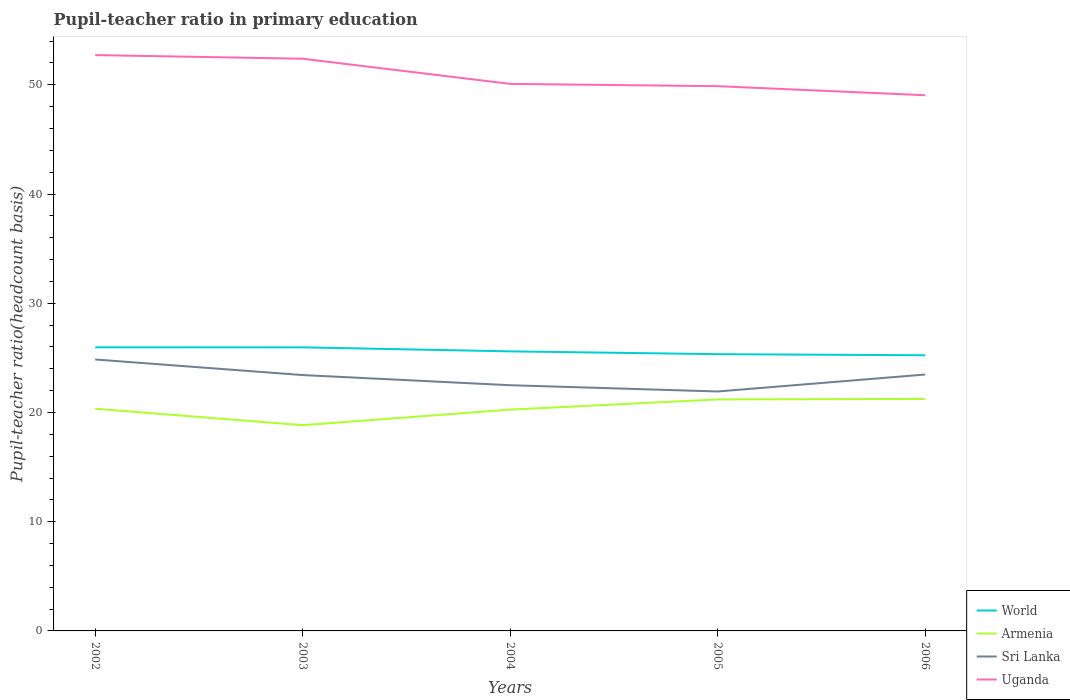How many different coloured lines are there?
Your answer should be very brief. 4. Does the line corresponding to World intersect with the line corresponding to Sri Lanka?
Provide a short and direct response. No. Is the number of lines equal to the number of legend labels?
Provide a succinct answer. Yes. Across all years, what is the maximum pupil-teacher ratio in primary education in Sri Lanka?
Offer a very short reply. 21.92. In which year was the pupil-teacher ratio in primary education in Armenia maximum?
Your response must be concise. 2003. What is the total pupil-teacher ratio in primary education in World in the graph?
Keep it short and to the point. 0.26. What is the difference between the highest and the second highest pupil-teacher ratio in primary education in Uganda?
Keep it short and to the point. 3.68. How many lines are there?
Your response must be concise. 4. Are the values on the major ticks of Y-axis written in scientific E-notation?
Your response must be concise. No. Does the graph contain grids?
Ensure brevity in your answer.  No. How are the legend labels stacked?
Offer a very short reply. Vertical. What is the title of the graph?
Provide a succinct answer. Pupil-teacher ratio in primary education. Does "Eritrea" appear as one of the legend labels in the graph?
Ensure brevity in your answer.  No. What is the label or title of the X-axis?
Offer a terse response. Years. What is the label or title of the Y-axis?
Your response must be concise. Pupil-teacher ratio(headcount basis). What is the Pupil-teacher ratio(headcount basis) in World in 2002?
Provide a succinct answer. 25.97. What is the Pupil-teacher ratio(headcount basis) of Armenia in 2002?
Offer a very short reply. 20.34. What is the Pupil-teacher ratio(headcount basis) of Sri Lanka in 2002?
Offer a terse response. 24.85. What is the Pupil-teacher ratio(headcount basis) of Uganda in 2002?
Keep it short and to the point. 52.72. What is the Pupil-teacher ratio(headcount basis) of World in 2003?
Your answer should be compact. 25.97. What is the Pupil-teacher ratio(headcount basis) in Armenia in 2003?
Offer a very short reply. 18.84. What is the Pupil-teacher ratio(headcount basis) of Sri Lanka in 2003?
Your answer should be very brief. 23.43. What is the Pupil-teacher ratio(headcount basis) of Uganda in 2003?
Your answer should be very brief. 52.39. What is the Pupil-teacher ratio(headcount basis) of World in 2004?
Your answer should be very brief. 25.6. What is the Pupil-teacher ratio(headcount basis) of Armenia in 2004?
Your answer should be compact. 20.26. What is the Pupil-teacher ratio(headcount basis) of Sri Lanka in 2004?
Provide a succinct answer. 22.5. What is the Pupil-teacher ratio(headcount basis) of Uganda in 2004?
Keep it short and to the point. 50.09. What is the Pupil-teacher ratio(headcount basis) of World in 2005?
Ensure brevity in your answer.  25.34. What is the Pupil-teacher ratio(headcount basis) in Armenia in 2005?
Give a very brief answer. 21.2. What is the Pupil-teacher ratio(headcount basis) of Sri Lanka in 2005?
Give a very brief answer. 21.92. What is the Pupil-teacher ratio(headcount basis) in Uganda in 2005?
Your answer should be compact. 49.88. What is the Pupil-teacher ratio(headcount basis) in World in 2006?
Keep it short and to the point. 25.24. What is the Pupil-teacher ratio(headcount basis) of Armenia in 2006?
Make the answer very short. 21.24. What is the Pupil-teacher ratio(headcount basis) of Sri Lanka in 2006?
Offer a very short reply. 23.48. What is the Pupil-teacher ratio(headcount basis) in Uganda in 2006?
Your response must be concise. 49.05. Across all years, what is the maximum Pupil-teacher ratio(headcount basis) in World?
Your answer should be compact. 25.97. Across all years, what is the maximum Pupil-teacher ratio(headcount basis) in Armenia?
Offer a terse response. 21.24. Across all years, what is the maximum Pupil-teacher ratio(headcount basis) in Sri Lanka?
Offer a very short reply. 24.85. Across all years, what is the maximum Pupil-teacher ratio(headcount basis) of Uganda?
Keep it short and to the point. 52.72. Across all years, what is the minimum Pupil-teacher ratio(headcount basis) in World?
Make the answer very short. 25.24. Across all years, what is the minimum Pupil-teacher ratio(headcount basis) of Armenia?
Offer a very short reply. 18.84. Across all years, what is the minimum Pupil-teacher ratio(headcount basis) in Sri Lanka?
Your answer should be very brief. 21.92. Across all years, what is the minimum Pupil-teacher ratio(headcount basis) of Uganda?
Give a very brief answer. 49.05. What is the total Pupil-teacher ratio(headcount basis) of World in the graph?
Give a very brief answer. 128.11. What is the total Pupil-teacher ratio(headcount basis) of Armenia in the graph?
Your answer should be compact. 101.88. What is the total Pupil-teacher ratio(headcount basis) of Sri Lanka in the graph?
Give a very brief answer. 116.18. What is the total Pupil-teacher ratio(headcount basis) of Uganda in the graph?
Your answer should be very brief. 254.12. What is the difference between the Pupil-teacher ratio(headcount basis) in World in 2002 and that in 2003?
Provide a short and direct response. 0. What is the difference between the Pupil-teacher ratio(headcount basis) in Armenia in 2002 and that in 2003?
Provide a short and direct response. 1.51. What is the difference between the Pupil-teacher ratio(headcount basis) in Sri Lanka in 2002 and that in 2003?
Provide a succinct answer. 1.43. What is the difference between the Pupil-teacher ratio(headcount basis) in Uganda in 2002 and that in 2003?
Offer a very short reply. 0.33. What is the difference between the Pupil-teacher ratio(headcount basis) of World in 2002 and that in 2004?
Provide a succinct answer. 0.37. What is the difference between the Pupil-teacher ratio(headcount basis) of Armenia in 2002 and that in 2004?
Your answer should be compact. 0.08. What is the difference between the Pupil-teacher ratio(headcount basis) in Sri Lanka in 2002 and that in 2004?
Provide a succinct answer. 2.36. What is the difference between the Pupil-teacher ratio(headcount basis) in Uganda in 2002 and that in 2004?
Keep it short and to the point. 2.64. What is the difference between the Pupil-teacher ratio(headcount basis) in World in 2002 and that in 2005?
Give a very brief answer. 0.63. What is the difference between the Pupil-teacher ratio(headcount basis) in Armenia in 2002 and that in 2005?
Offer a very short reply. -0.85. What is the difference between the Pupil-teacher ratio(headcount basis) in Sri Lanka in 2002 and that in 2005?
Make the answer very short. 2.93. What is the difference between the Pupil-teacher ratio(headcount basis) in Uganda in 2002 and that in 2005?
Keep it short and to the point. 2.85. What is the difference between the Pupil-teacher ratio(headcount basis) in World in 2002 and that in 2006?
Make the answer very short. 0.73. What is the difference between the Pupil-teacher ratio(headcount basis) in Armenia in 2002 and that in 2006?
Keep it short and to the point. -0.9. What is the difference between the Pupil-teacher ratio(headcount basis) of Sri Lanka in 2002 and that in 2006?
Make the answer very short. 1.38. What is the difference between the Pupil-teacher ratio(headcount basis) of Uganda in 2002 and that in 2006?
Offer a terse response. 3.68. What is the difference between the Pupil-teacher ratio(headcount basis) of World in 2003 and that in 2004?
Make the answer very short. 0.37. What is the difference between the Pupil-teacher ratio(headcount basis) of Armenia in 2003 and that in 2004?
Your response must be concise. -1.43. What is the difference between the Pupil-teacher ratio(headcount basis) in Sri Lanka in 2003 and that in 2004?
Offer a very short reply. 0.93. What is the difference between the Pupil-teacher ratio(headcount basis) of Uganda in 2003 and that in 2004?
Provide a short and direct response. 2.3. What is the difference between the Pupil-teacher ratio(headcount basis) in World in 2003 and that in 2005?
Your answer should be very brief. 0.63. What is the difference between the Pupil-teacher ratio(headcount basis) in Armenia in 2003 and that in 2005?
Keep it short and to the point. -2.36. What is the difference between the Pupil-teacher ratio(headcount basis) in Sri Lanka in 2003 and that in 2005?
Your answer should be very brief. 1.5. What is the difference between the Pupil-teacher ratio(headcount basis) of Uganda in 2003 and that in 2005?
Keep it short and to the point. 2.51. What is the difference between the Pupil-teacher ratio(headcount basis) of World in 2003 and that in 2006?
Ensure brevity in your answer.  0.73. What is the difference between the Pupil-teacher ratio(headcount basis) in Armenia in 2003 and that in 2006?
Offer a terse response. -2.4. What is the difference between the Pupil-teacher ratio(headcount basis) of Sri Lanka in 2003 and that in 2006?
Give a very brief answer. -0.05. What is the difference between the Pupil-teacher ratio(headcount basis) in Uganda in 2003 and that in 2006?
Your answer should be very brief. 3.34. What is the difference between the Pupil-teacher ratio(headcount basis) of World in 2004 and that in 2005?
Make the answer very short. 0.26. What is the difference between the Pupil-teacher ratio(headcount basis) of Armenia in 2004 and that in 2005?
Your answer should be compact. -0.93. What is the difference between the Pupil-teacher ratio(headcount basis) of Sri Lanka in 2004 and that in 2005?
Offer a very short reply. 0.57. What is the difference between the Pupil-teacher ratio(headcount basis) of Uganda in 2004 and that in 2005?
Provide a short and direct response. 0.21. What is the difference between the Pupil-teacher ratio(headcount basis) of World in 2004 and that in 2006?
Make the answer very short. 0.36. What is the difference between the Pupil-teacher ratio(headcount basis) in Armenia in 2004 and that in 2006?
Offer a very short reply. -0.98. What is the difference between the Pupil-teacher ratio(headcount basis) of Sri Lanka in 2004 and that in 2006?
Provide a succinct answer. -0.98. What is the difference between the Pupil-teacher ratio(headcount basis) in Uganda in 2004 and that in 2006?
Your answer should be very brief. 1.04. What is the difference between the Pupil-teacher ratio(headcount basis) in World in 2005 and that in 2006?
Your response must be concise. 0.1. What is the difference between the Pupil-teacher ratio(headcount basis) of Armenia in 2005 and that in 2006?
Give a very brief answer. -0.04. What is the difference between the Pupil-teacher ratio(headcount basis) of Sri Lanka in 2005 and that in 2006?
Give a very brief answer. -1.55. What is the difference between the Pupil-teacher ratio(headcount basis) in Uganda in 2005 and that in 2006?
Provide a short and direct response. 0.83. What is the difference between the Pupil-teacher ratio(headcount basis) of World in 2002 and the Pupil-teacher ratio(headcount basis) of Armenia in 2003?
Give a very brief answer. 7.13. What is the difference between the Pupil-teacher ratio(headcount basis) of World in 2002 and the Pupil-teacher ratio(headcount basis) of Sri Lanka in 2003?
Provide a short and direct response. 2.54. What is the difference between the Pupil-teacher ratio(headcount basis) of World in 2002 and the Pupil-teacher ratio(headcount basis) of Uganda in 2003?
Give a very brief answer. -26.42. What is the difference between the Pupil-teacher ratio(headcount basis) of Armenia in 2002 and the Pupil-teacher ratio(headcount basis) of Sri Lanka in 2003?
Offer a very short reply. -3.08. What is the difference between the Pupil-teacher ratio(headcount basis) of Armenia in 2002 and the Pupil-teacher ratio(headcount basis) of Uganda in 2003?
Give a very brief answer. -32.05. What is the difference between the Pupil-teacher ratio(headcount basis) in Sri Lanka in 2002 and the Pupil-teacher ratio(headcount basis) in Uganda in 2003?
Your answer should be compact. -27.54. What is the difference between the Pupil-teacher ratio(headcount basis) of World in 2002 and the Pupil-teacher ratio(headcount basis) of Armenia in 2004?
Offer a terse response. 5.71. What is the difference between the Pupil-teacher ratio(headcount basis) in World in 2002 and the Pupil-teacher ratio(headcount basis) in Sri Lanka in 2004?
Your response must be concise. 3.47. What is the difference between the Pupil-teacher ratio(headcount basis) in World in 2002 and the Pupil-teacher ratio(headcount basis) in Uganda in 2004?
Offer a terse response. -24.12. What is the difference between the Pupil-teacher ratio(headcount basis) of Armenia in 2002 and the Pupil-teacher ratio(headcount basis) of Sri Lanka in 2004?
Your answer should be compact. -2.15. What is the difference between the Pupil-teacher ratio(headcount basis) of Armenia in 2002 and the Pupil-teacher ratio(headcount basis) of Uganda in 2004?
Your answer should be compact. -29.74. What is the difference between the Pupil-teacher ratio(headcount basis) in Sri Lanka in 2002 and the Pupil-teacher ratio(headcount basis) in Uganda in 2004?
Offer a very short reply. -25.23. What is the difference between the Pupil-teacher ratio(headcount basis) in World in 2002 and the Pupil-teacher ratio(headcount basis) in Armenia in 2005?
Your answer should be compact. 4.77. What is the difference between the Pupil-teacher ratio(headcount basis) of World in 2002 and the Pupil-teacher ratio(headcount basis) of Sri Lanka in 2005?
Your answer should be very brief. 4.04. What is the difference between the Pupil-teacher ratio(headcount basis) in World in 2002 and the Pupil-teacher ratio(headcount basis) in Uganda in 2005?
Your answer should be compact. -23.91. What is the difference between the Pupil-teacher ratio(headcount basis) of Armenia in 2002 and the Pupil-teacher ratio(headcount basis) of Sri Lanka in 2005?
Offer a terse response. -1.58. What is the difference between the Pupil-teacher ratio(headcount basis) of Armenia in 2002 and the Pupil-teacher ratio(headcount basis) of Uganda in 2005?
Provide a succinct answer. -29.53. What is the difference between the Pupil-teacher ratio(headcount basis) of Sri Lanka in 2002 and the Pupil-teacher ratio(headcount basis) of Uganda in 2005?
Give a very brief answer. -25.02. What is the difference between the Pupil-teacher ratio(headcount basis) in World in 2002 and the Pupil-teacher ratio(headcount basis) in Armenia in 2006?
Provide a succinct answer. 4.73. What is the difference between the Pupil-teacher ratio(headcount basis) in World in 2002 and the Pupil-teacher ratio(headcount basis) in Sri Lanka in 2006?
Your answer should be very brief. 2.49. What is the difference between the Pupil-teacher ratio(headcount basis) of World in 2002 and the Pupil-teacher ratio(headcount basis) of Uganda in 2006?
Provide a short and direct response. -23.08. What is the difference between the Pupil-teacher ratio(headcount basis) in Armenia in 2002 and the Pupil-teacher ratio(headcount basis) in Sri Lanka in 2006?
Your response must be concise. -3.13. What is the difference between the Pupil-teacher ratio(headcount basis) of Armenia in 2002 and the Pupil-teacher ratio(headcount basis) of Uganda in 2006?
Give a very brief answer. -28.7. What is the difference between the Pupil-teacher ratio(headcount basis) of Sri Lanka in 2002 and the Pupil-teacher ratio(headcount basis) of Uganda in 2006?
Ensure brevity in your answer.  -24.19. What is the difference between the Pupil-teacher ratio(headcount basis) in World in 2003 and the Pupil-teacher ratio(headcount basis) in Armenia in 2004?
Offer a terse response. 5.7. What is the difference between the Pupil-teacher ratio(headcount basis) in World in 2003 and the Pupil-teacher ratio(headcount basis) in Sri Lanka in 2004?
Provide a short and direct response. 3.47. What is the difference between the Pupil-teacher ratio(headcount basis) of World in 2003 and the Pupil-teacher ratio(headcount basis) of Uganda in 2004?
Ensure brevity in your answer.  -24.12. What is the difference between the Pupil-teacher ratio(headcount basis) of Armenia in 2003 and the Pupil-teacher ratio(headcount basis) of Sri Lanka in 2004?
Provide a short and direct response. -3.66. What is the difference between the Pupil-teacher ratio(headcount basis) in Armenia in 2003 and the Pupil-teacher ratio(headcount basis) in Uganda in 2004?
Keep it short and to the point. -31.25. What is the difference between the Pupil-teacher ratio(headcount basis) in Sri Lanka in 2003 and the Pupil-teacher ratio(headcount basis) in Uganda in 2004?
Your answer should be compact. -26.66. What is the difference between the Pupil-teacher ratio(headcount basis) in World in 2003 and the Pupil-teacher ratio(headcount basis) in Armenia in 2005?
Your answer should be compact. 4.77. What is the difference between the Pupil-teacher ratio(headcount basis) in World in 2003 and the Pupil-teacher ratio(headcount basis) in Sri Lanka in 2005?
Offer a terse response. 4.04. What is the difference between the Pupil-teacher ratio(headcount basis) in World in 2003 and the Pupil-teacher ratio(headcount basis) in Uganda in 2005?
Your answer should be very brief. -23.91. What is the difference between the Pupil-teacher ratio(headcount basis) in Armenia in 2003 and the Pupil-teacher ratio(headcount basis) in Sri Lanka in 2005?
Offer a very short reply. -3.09. What is the difference between the Pupil-teacher ratio(headcount basis) in Armenia in 2003 and the Pupil-teacher ratio(headcount basis) in Uganda in 2005?
Your response must be concise. -31.04. What is the difference between the Pupil-teacher ratio(headcount basis) of Sri Lanka in 2003 and the Pupil-teacher ratio(headcount basis) of Uganda in 2005?
Your answer should be compact. -26.45. What is the difference between the Pupil-teacher ratio(headcount basis) of World in 2003 and the Pupil-teacher ratio(headcount basis) of Armenia in 2006?
Keep it short and to the point. 4.72. What is the difference between the Pupil-teacher ratio(headcount basis) in World in 2003 and the Pupil-teacher ratio(headcount basis) in Sri Lanka in 2006?
Offer a very short reply. 2.49. What is the difference between the Pupil-teacher ratio(headcount basis) in World in 2003 and the Pupil-teacher ratio(headcount basis) in Uganda in 2006?
Your answer should be compact. -23.08. What is the difference between the Pupil-teacher ratio(headcount basis) in Armenia in 2003 and the Pupil-teacher ratio(headcount basis) in Sri Lanka in 2006?
Offer a terse response. -4.64. What is the difference between the Pupil-teacher ratio(headcount basis) in Armenia in 2003 and the Pupil-teacher ratio(headcount basis) in Uganda in 2006?
Your response must be concise. -30.21. What is the difference between the Pupil-teacher ratio(headcount basis) of Sri Lanka in 2003 and the Pupil-teacher ratio(headcount basis) of Uganda in 2006?
Your response must be concise. -25.62. What is the difference between the Pupil-teacher ratio(headcount basis) of World in 2004 and the Pupil-teacher ratio(headcount basis) of Armenia in 2005?
Provide a short and direct response. 4.4. What is the difference between the Pupil-teacher ratio(headcount basis) in World in 2004 and the Pupil-teacher ratio(headcount basis) in Sri Lanka in 2005?
Give a very brief answer. 3.67. What is the difference between the Pupil-teacher ratio(headcount basis) of World in 2004 and the Pupil-teacher ratio(headcount basis) of Uganda in 2005?
Offer a very short reply. -24.28. What is the difference between the Pupil-teacher ratio(headcount basis) of Armenia in 2004 and the Pupil-teacher ratio(headcount basis) of Sri Lanka in 2005?
Provide a short and direct response. -1.66. What is the difference between the Pupil-teacher ratio(headcount basis) of Armenia in 2004 and the Pupil-teacher ratio(headcount basis) of Uganda in 2005?
Keep it short and to the point. -29.62. What is the difference between the Pupil-teacher ratio(headcount basis) of Sri Lanka in 2004 and the Pupil-teacher ratio(headcount basis) of Uganda in 2005?
Provide a short and direct response. -27.38. What is the difference between the Pupil-teacher ratio(headcount basis) of World in 2004 and the Pupil-teacher ratio(headcount basis) of Armenia in 2006?
Give a very brief answer. 4.35. What is the difference between the Pupil-teacher ratio(headcount basis) in World in 2004 and the Pupil-teacher ratio(headcount basis) in Sri Lanka in 2006?
Keep it short and to the point. 2.12. What is the difference between the Pupil-teacher ratio(headcount basis) of World in 2004 and the Pupil-teacher ratio(headcount basis) of Uganda in 2006?
Provide a short and direct response. -23.45. What is the difference between the Pupil-teacher ratio(headcount basis) in Armenia in 2004 and the Pupil-teacher ratio(headcount basis) in Sri Lanka in 2006?
Keep it short and to the point. -3.21. What is the difference between the Pupil-teacher ratio(headcount basis) in Armenia in 2004 and the Pupil-teacher ratio(headcount basis) in Uganda in 2006?
Your answer should be compact. -28.78. What is the difference between the Pupil-teacher ratio(headcount basis) of Sri Lanka in 2004 and the Pupil-teacher ratio(headcount basis) of Uganda in 2006?
Keep it short and to the point. -26.55. What is the difference between the Pupil-teacher ratio(headcount basis) of World in 2005 and the Pupil-teacher ratio(headcount basis) of Armenia in 2006?
Ensure brevity in your answer.  4.1. What is the difference between the Pupil-teacher ratio(headcount basis) of World in 2005 and the Pupil-teacher ratio(headcount basis) of Sri Lanka in 2006?
Keep it short and to the point. 1.86. What is the difference between the Pupil-teacher ratio(headcount basis) in World in 2005 and the Pupil-teacher ratio(headcount basis) in Uganda in 2006?
Keep it short and to the point. -23.71. What is the difference between the Pupil-teacher ratio(headcount basis) in Armenia in 2005 and the Pupil-teacher ratio(headcount basis) in Sri Lanka in 2006?
Your answer should be compact. -2.28. What is the difference between the Pupil-teacher ratio(headcount basis) in Armenia in 2005 and the Pupil-teacher ratio(headcount basis) in Uganda in 2006?
Your response must be concise. -27.85. What is the difference between the Pupil-teacher ratio(headcount basis) in Sri Lanka in 2005 and the Pupil-teacher ratio(headcount basis) in Uganda in 2006?
Provide a short and direct response. -27.12. What is the average Pupil-teacher ratio(headcount basis) in World per year?
Your answer should be very brief. 25.62. What is the average Pupil-teacher ratio(headcount basis) in Armenia per year?
Provide a succinct answer. 20.38. What is the average Pupil-teacher ratio(headcount basis) of Sri Lanka per year?
Your response must be concise. 23.24. What is the average Pupil-teacher ratio(headcount basis) of Uganda per year?
Keep it short and to the point. 50.83. In the year 2002, what is the difference between the Pupil-teacher ratio(headcount basis) in World and Pupil-teacher ratio(headcount basis) in Armenia?
Offer a terse response. 5.62. In the year 2002, what is the difference between the Pupil-teacher ratio(headcount basis) of World and Pupil-teacher ratio(headcount basis) of Sri Lanka?
Your response must be concise. 1.12. In the year 2002, what is the difference between the Pupil-teacher ratio(headcount basis) of World and Pupil-teacher ratio(headcount basis) of Uganda?
Offer a terse response. -26.76. In the year 2002, what is the difference between the Pupil-teacher ratio(headcount basis) in Armenia and Pupil-teacher ratio(headcount basis) in Sri Lanka?
Your response must be concise. -4.51. In the year 2002, what is the difference between the Pupil-teacher ratio(headcount basis) in Armenia and Pupil-teacher ratio(headcount basis) in Uganda?
Provide a short and direct response. -32.38. In the year 2002, what is the difference between the Pupil-teacher ratio(headcount basis) of Sri Lanka and Pupil-teacher ratio(headcount basis) of Uganda?
Provide a short and direct response. -27.87. In the year 2003, what is the difference between the Pupil-teacher ratio(headcount basis) in World and Pupil-teacher ratio(headcount basis) in Armenia?
Provide a succinct answer. 7.13. In the year 2003, what is the difference between the Pupil-teacher ratio(headcount basis) of World and Pupil-teacher ratio(headcount basis) of Sri Lanka?
Your answer should be very brief. 2.54. In the year 2003, what is the difference between the Pupil-teacher ratio(headcount basis) in World and Pupil-teacher ratio(headcount basis) in Uganda?
Your answer should be very brief. -26.42. In the year 2003, what is the difference between the Pupil-teacher ratio(headcount basis) in Armenia and Pupil-teacher ratio(headcount basis) in Sri Lanka?
Make the answer very short. -4.59. In the year 2003, what is the difference between the Pupil-teacher ratio(headcount basis) in Armenia and Pupil-teacher ratio(headcount basis) in Uganda?
Offer a terse response. -33.55. In the year 2003, what is the difference between the Pupil-teacher ratio(headcount basis) in Sri Lanka and Pupil-teacher ratio(headcount basis) in Uganda?
Offer a terse response. -28.96. In the year 2004, what is the difference between the Pupil-teacher ratio(headcount basis) in World and Pupil-teacher ratio(headcount basis) in Armenia?
Offer a very short reply. 5.33. In the year 2004, what is the difference between the Pupil-teacher ratio(headcount basis) in World and Pupil-teacher ratio(headcount basis) in Sri Lanka?
Keep it short and to the point. 3.1. In the year 2004, what is the difference between the Pupil-teacher ratio(headcount basis) of World and Pupil-teacher ratio(headcount basis) of Uganda?
Your response must be concise. -24.49. In the year 2004, what is the difference between the Pupil-teacher ratio(headcount basis) in Armenia and Pupil-teacher ratio(headcount basis) in Sri Lanka?
Give a very brief answer. -2.23. In the year 2004, what is the difference between the Pupil-teacher ratio(headcount basis) in Armenia and Pupil-teacher ratio(headcount basis) in Uganda?
Your response must be concise. -29.82. In the year 2004, what is the difference between the Pupil-teacher ratio(headcount basis) of Sri Lanka and Pupil-teacher ratio(headcount basis) of Uganda?
Your answer should be compact. -27.59. In the year 2005, what is the difference between the Pupil-teacher ratio(headcount basis) of World and Pupil-teacher ratio(headcount basis) of Armenia?
Make the answer very short. 4.14. In the year 2005, what is the difference between the Pupil-teacher ratio(headcount basis) of World and Pupil-teacher ratio(headcount basis) of Sri Lanka?
Make the answer very short. 3.42. In the year 2005, what is the difference between the Pupil-teacher ratio(headcount basis) in World and Pupil-teacher ratio(headcount basis) in Uganda?
Your response must be concise. -24.54. In the year 2005, what is the difference between the Pupil-teacher ratio(headcount basis) in Armenia and Pupil-teacher ratio(headcount basis) in Sri Lanka?
Offer a very short reply. -0.73. In the year 2005, what is the difference between the Pupil-teacher ratio(headcount basis) in Armenia and Pupil-teacher ratio(headcount basis) in Uganda?
Keep it short and to the point. -28.68. In the year 2005, what is the difference between the Pupil-teacher ratio(headcount basis) in Sri Lanka and Pupil-teacher ratio(headcount basis) in Uganda?
Your answer should be very brief. -27.95. In the year 2006, what is the difference between the Pupil-teacher ratio(headcount basis) of World and Pupil-teacher ratio(headcount basis) of Armenia?
Ensure brevity in your answer.  4. In the year 2006, what is the difference between the Pupil-teacher ratio(headcount basis) in World and Pupil-teacher ratio(headcount basis) in Sri Lanka?
Ensure brevity in your answer.  1.76. In the year 2006, what is the difference between the Pupil-teacher ratio(headcount basis) of World and Pupil-teacher ratio(headcount basis) of Uganda?
Offer a terse response. -23.81. In the year 2006, what is the difference between the Pupil-teacher ratio(headcount basis) in Armenia and Pupil-teacher ratio(headcount basis) in Sri Lanka?
Ensure brevity in your answer.  -2.23. In the year 2006, what is the difference between the Pupil-teacher ratio(headcount basis) of Armenia and Pupil-teacher ratio(headcount basis) of Uganda?
Provide a short and direct response. -27.81. In the year 2006, what is the difference between the Pupil-teacher ratio(headcount basis) in Sri Lanka and Pupil-teacher ratio(headcount basis) in Uganda?
Provide a short and direct response. -25.57. What is the ratio of the Pupil-teacher ratio(headcount basis) in World in 2002 to that in 2003?
Give a very brief answer. 1. What is the ratio of the Pupil-teacher ratio(headcount basis) in Sri Lanka in 2002 to that in 2003?
Keep it short and to the point. 1.06. What is the ratio of the Pupil-teacher ratio(headcount basis) in Uganda in 2002 to that in 2003?
Give a very brief answer. 1.01. What is the ratio of the Pupil-teacher ratio(headcount basis) in World in 2002 to that in 2004?
Offer a terse response. 1.01. What is the ratio of the Pupil-teacher ratio(headcount basis) of Sri Lanka in 2002 to that in 2004?
Provide a succinct answer. 1.1. What is the ratio of the Pupil-teacher ratio(headcount basis) in Uganda in 2002 to that in 2004?
Your response must be concise. 1.05. What is the ratio of the Pupil-teacher ratio(headcount basis) in World in 2002 to that in 2005?
Ensure brevity in your answer.  1.02. What is the ratio of the Pupil-teacher ratio(headcount basis) in Armenia in 2002 to that in 2005?
Your response must be concise. 0.96. What is the ratio of the Pupil-teacher ratio(headcount basis) of Sri Lanka in 2002 to that in 2005?
Your response must be concise. 1.13. What is the ratio of the Pupil-teacher ratio(headcount basis) in Uganda in 2002 to that in 2005?
Give a very brief answer. 1.06. What is the ratio of the Pupil-teacher ratio(headcount basis) in World in 2002 to that in 2006?
Offer a terse response. 1.03. What is the ratio of the Pupil-teacher ratio(headcount basis) of Armenia in 2002 to that in 2006?
Your response must be concise. 0.96. What is the ratio of the Pupil-teacher ratio(headcount basis) of Sri Lanka in 2002 to that in 2006?
Provide a succinct answer. 1.06. What is the ratio of the Pupil-teacher ratio(headcount basis) in Uganda in 2002 to that in 2006?
Offer a terse response. 1.07. What is the ratio of the Pupil-teacher ratio(headcount basis) of World in 2003 to that in 2004?
Your answer should be compact. 1.01. What is the ratio of the Pupil-teacher ratio(headcount basis) of Armenia in 2003 to that in 2004?
Your response must be concise. 0.93. What is the ratio of the Pupil-teacher ratio(headcount basis) of Sri Lanka in 2003 to that in 2004?
Provide a succinct answer. 1.04. What is the ratio of the Pupil-teacher ratio(headcount basis) of Uganda in 2003 to that in 2004?
Keep it short and to the point. 1.05. What is the ratio of the Pupil-teacher ratio(headcount basis) in World in 2003 to that in 2005?
Your response must be concise. 1.02. What is the ratio of the Pupil-teacher ratio(headcount basis) in Armenia in 2003 to that in 2005?
Give a very brief answer. 0.89. What is the ratio of the Pupil-teacher ratio(headcount basis) of Sri Lanka in 2003 to that in 2005?
Offer a very short reply. 1.07. What is the ratio of the Pupil-teacher ratio(headcount basis) of Uganda in 2003 to that in 2005?
Offer a very short reply. 1.05. What is the ratio of the Pupil-teacher ratio(headcount basis) in World in 2003 to that in 2006?
Your answer should be very brief. 1.03. What is the ratio of the Pupil-teacher ratio(headcount basis) of Armenia in 2003 to that in 2006?
Make the answer very short. 0.89. What is the ratio of the Pupil-teacher ratio(headcount basis) of Uganda in 2003 to that in 2006?
Keep it short and to the point. 1.07. What is the ratio of the Pupil-teacher ratio(headcount basis) of Armenia in 2004 to that in 2005?
Offer a terse response. 0.96. What is the ratio of the Pupil-teacher ratio(headcount basis) of Sri Lanka in 2004 to that in 2005?
Ensure brevity in your answer.  1.03. What is the ratio of the Pupil-teacher ratio(headcount basis) of World in 2004 to that in 2006?
Provide a short and direct response. 1.01. What is the ratio of the Pupil-teacher ratio(headcount basis) of Armenia in 2004 to that in 2006?
Provide a short and direct response. 0.95. What is the ratio of the Pupil-teacher ratio(headcount basis) in Uganda in 2004 to that in 2006?
Offer a terse response. 1.02. What is the ratio of the Pupil-teacher ratio(headcount basis) in Armenia in 2005 to that in 2006?
Keep it short and to the point. 1. What is the ratio of the Pupil-teacher ratio(headcount basis) in Sri Lanka in 2005 to that in 2006?
Your answer should be compact. 0.93. What is the ratio of the Pupil-teacher ratio(headcount basis) in Uganda in 2005 to that in 2006?
Give a very brief answer. 1.02. What is the difference between the highest and the second highest Pupil-teacher ratio(headcount basis) of World?
Ensure brevity in your answer.  0. What is the difference between the highest and the second highest Pupil-teacher ratio(headcount basis) in Armenia?
Ensure brevity in your answer.  0.04. What is the difference between the highest and the second highest Pupil-teacher ratio(headcount basis) of Sri Lanka?
Make the answer very short. 1.38. What is the difference between the highest and the second highest Pupil-teacher ratio(headcount basis) of Uganda?
Your answer should be compact. 0.33. What is the difference between the highest and the lowest Pupil-teacher ratio(headcount basis) of World?
Keep it short and to the point. 0.73. What is the difference between the highest and the lowest Pupil-teacher ratio(headcount basis) in Armenia?
Give a very brief answer. 2.4. What is the difference between the highest and the lowest Pupil-teacher ratio(headcount basis) of Sri Lanka?
Your response must be concise. 2.93. What is the difference between the highest and the lowest Pupil-teacher ratio(headcount basis) of Uganda?
Your answer should be compact. 3.68. 